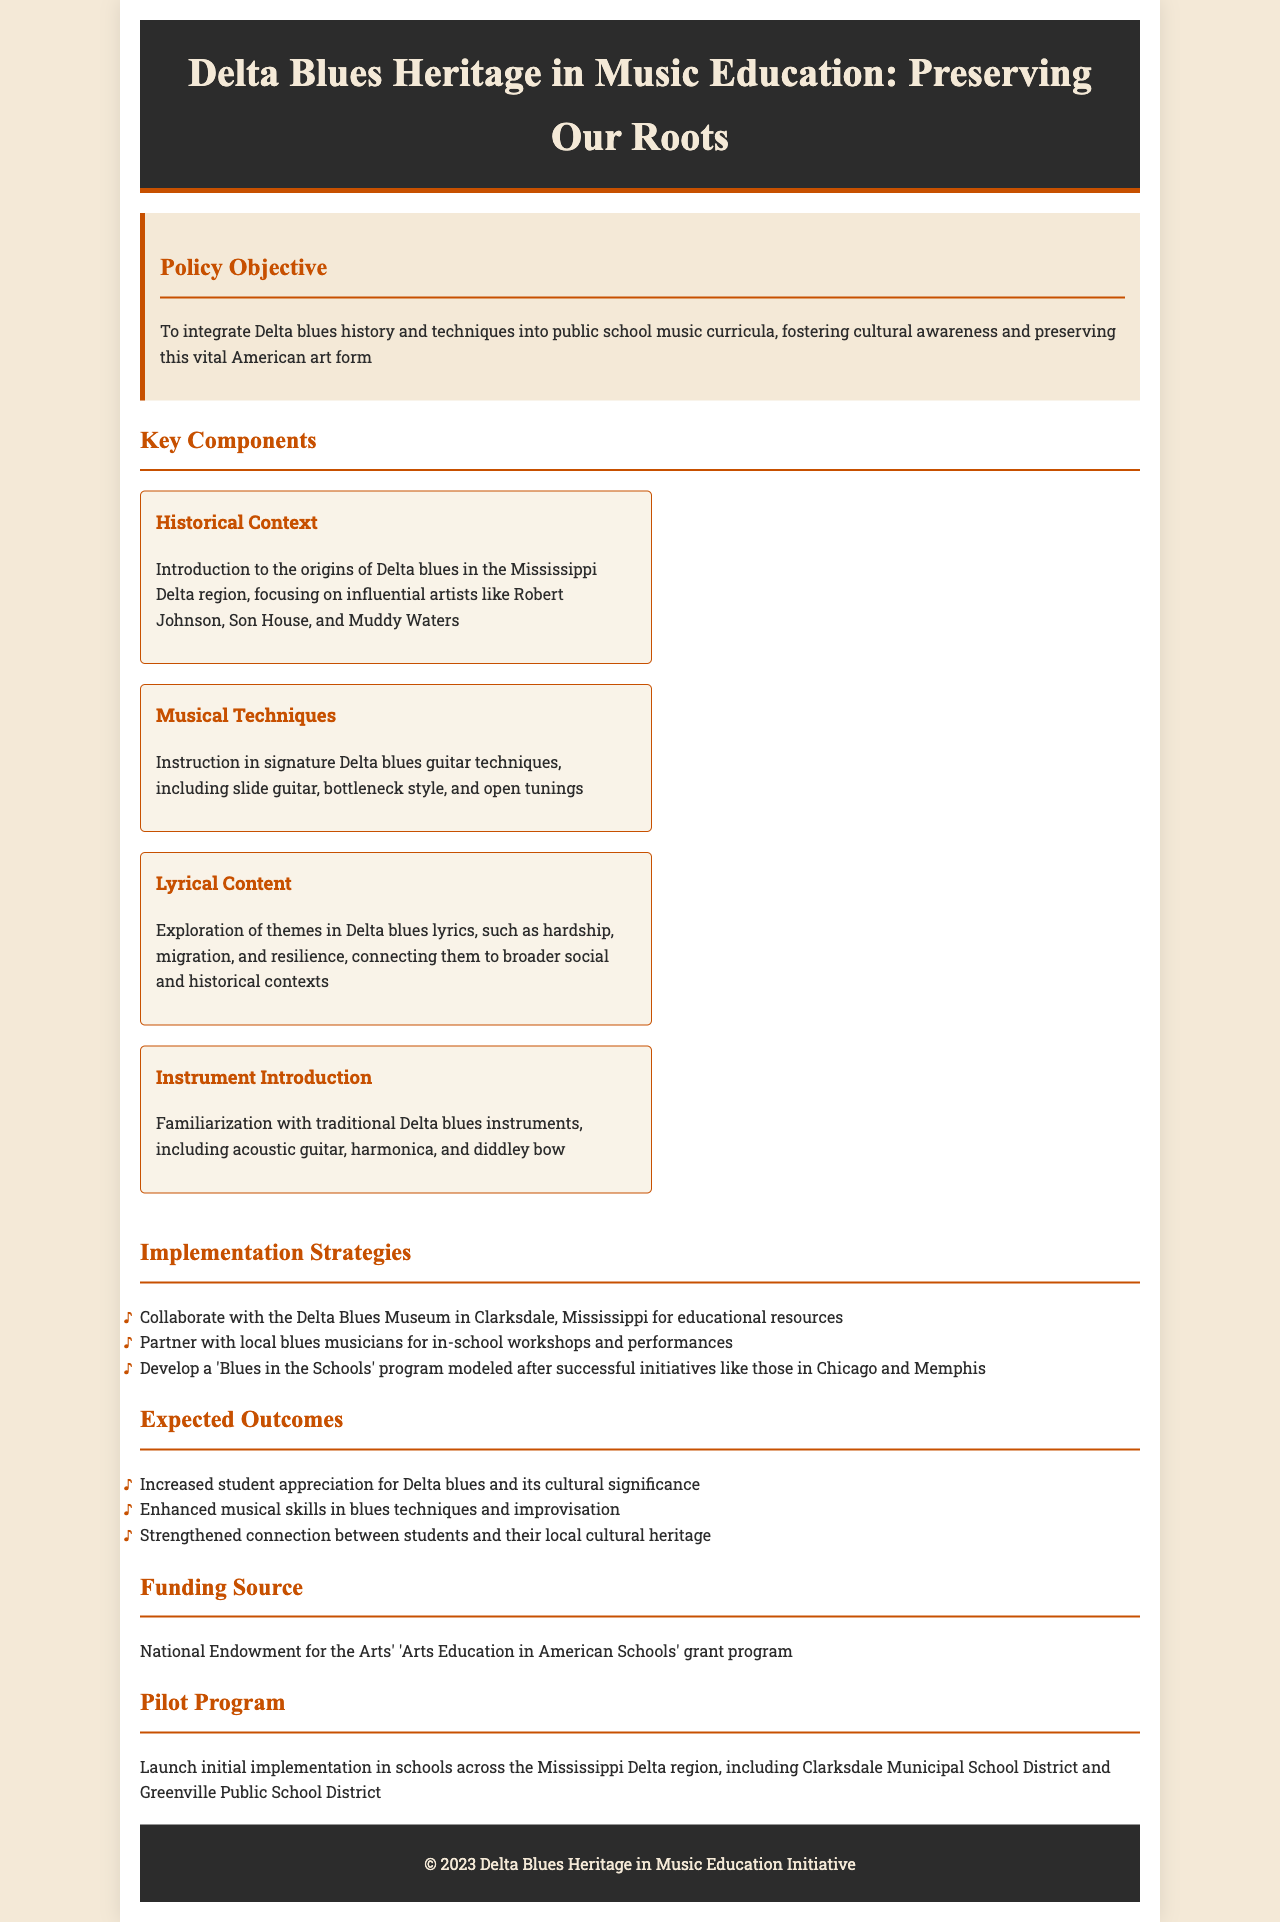What is the main objective of the policy? The main objective is to integrate Delta blues history and techniques into public school music curricula, fostering cultural awareness and preserving this vital American art form.
Answer: to integrate Delta blues history and techniques into public school music curricula Who are some influential artists mentioned in the historical context? Influential artists mentioned include Robert Johnson, Son House, and Muddy Waters.
Answer: Robert Johnson, Son House, Muddy Waters What musical technique is emphasized in the curriculum? The curriculum emphasizes instruction in signature Delta blues guitar techniques, including slide guitar, bottleneck style, and open tunings.
Answer: slide guitar, bottleneck style, and open tunings What is one of the implementation strategies? One of the implementation strategies is to collaborate with the Delta Blues Museum in Clarksdale, Mississippi for educational resources.
Answer: collaborate with the Delta Blues Museum What funding source is identified for the program? The funding source identified is the National Endowment for the Arts' 'Arts Education in American Schools' grant program.
Answer: National Endowment for the Arts' 'Arts Education in American Schools' grant program Which districts will pilot the program? The pilot program will launch in schools across the Clarksdale Municipal School District and Greenville Public School District.
Answer: Clarksdale Municipal School District and Greenville Public School District 